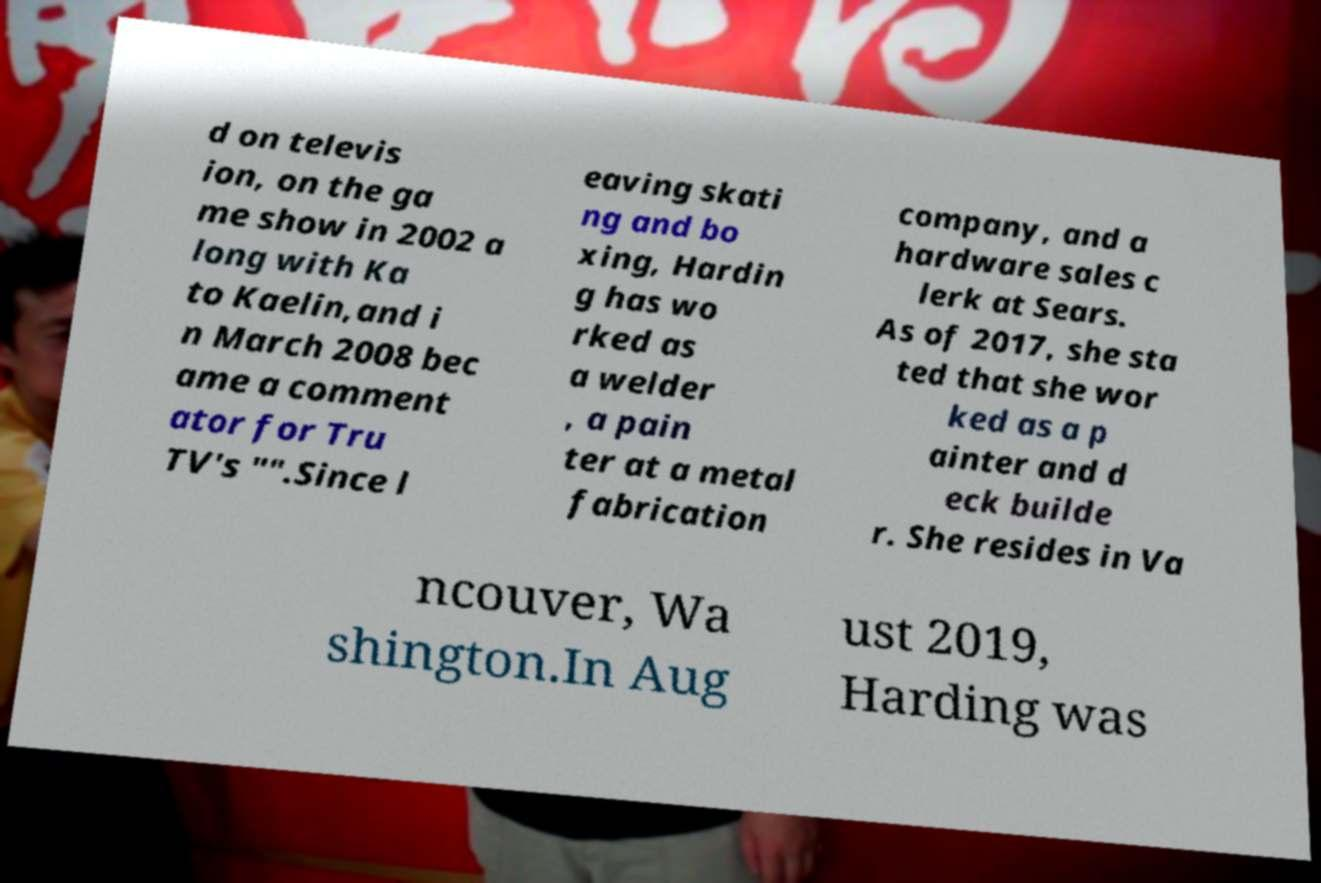For documentation purposes, I need the text within this image transcribed. Could you provide that? d on televis ion, on the ga me show in 2002 a long with Ka to Kaelin,and i n March 2008 bec ame a comment ator for Tru TV's "".Since l eaving skati ng and bo xing, Hardin g has wo rked as a welder , a pain ter at a metal fabrication company, and a hardware sales c lerk at Sears. As of 2017, she sta ted that she wor ked as a p ainter and d eck builde r. She resides in Va ncouver, Wa shington.In Aug ust 2019, Harding was 